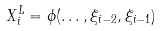Convert formula to latex. <formula><loc_0><loc_0><loc_500><loc_500>X ^ { L } _ { i } = \phi ( \dots , \xi _ { i - 2 } , \xi _ { i - 1 } )</formula> 